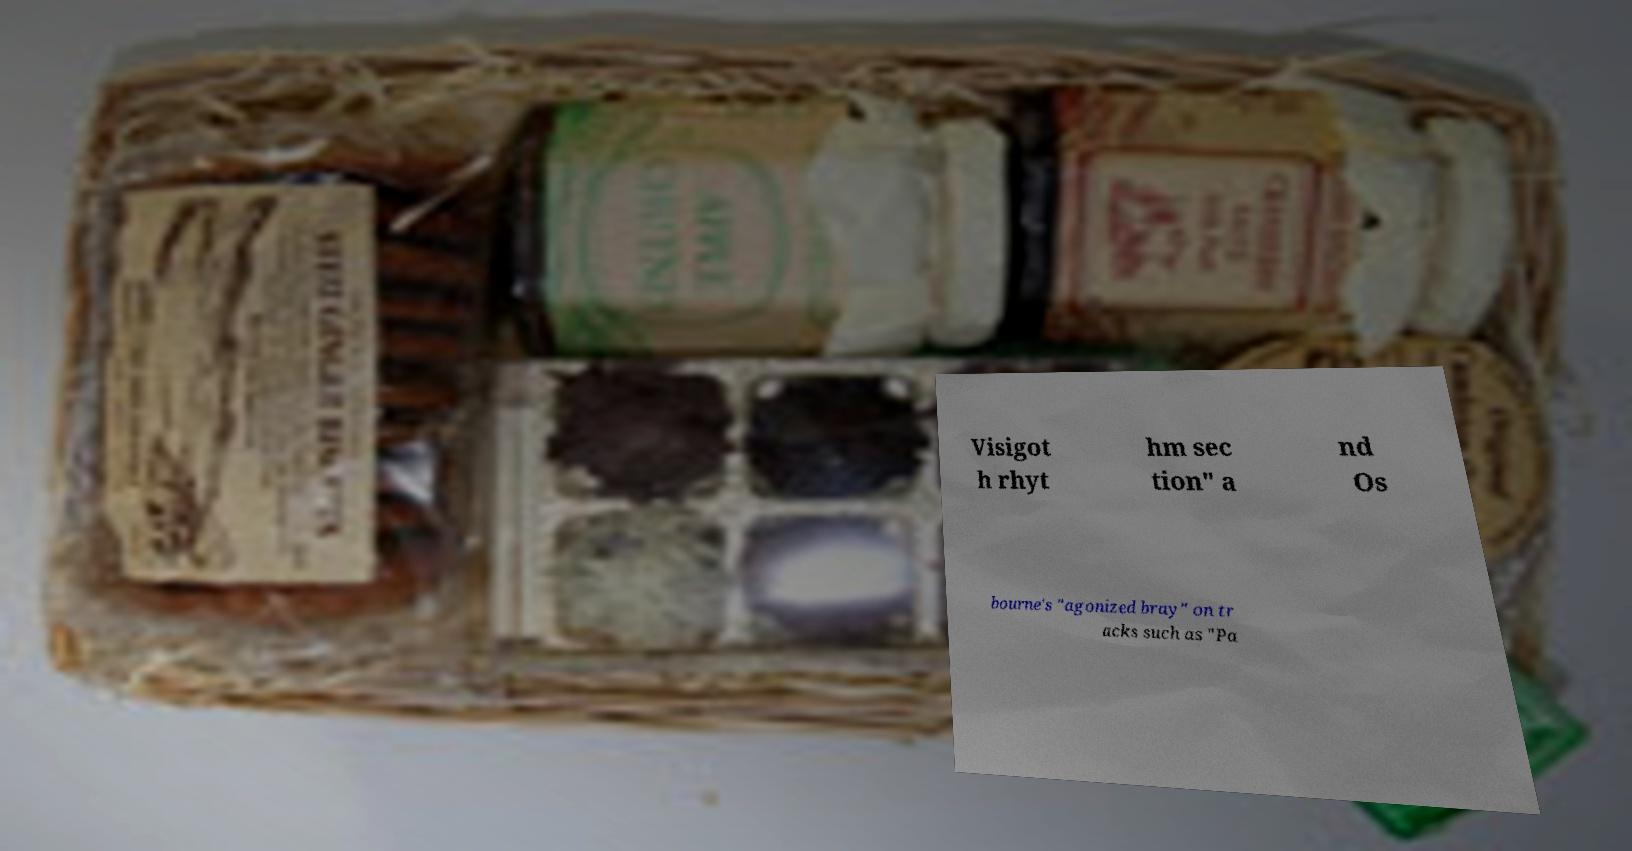What messages or text are displayed in this image? I need them in a readable, typed format. Visigot h rhyt hm sec tion" a nd Os bourne's "agonized bray" on tr acks such as "Pa 